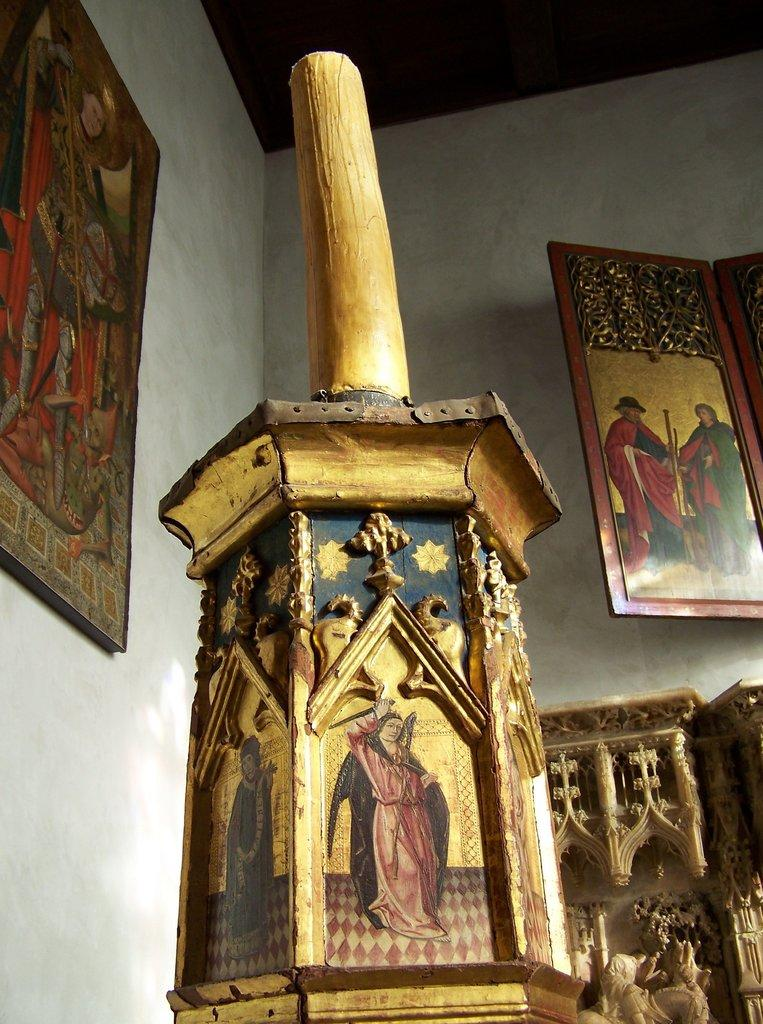What type of object is made of wood in the image? There is a wooden object in the image, but the specific type cannot be determined from the provided facts. What can be seen in the background of the image? There are walls visible in the background of the image. Is there any decoration or item on the walls? Yes, there is a photo on one of the walls. How many cords are connected to the wooden object in the image? There is no mention of cords in the provided facts, so it cannot be determined if any are connected to the wooden object. 